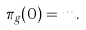<formula> <loc_0><loc_0><loc_500><loc_500>\pi _ { g } ( 0 ) = m .</formula> 